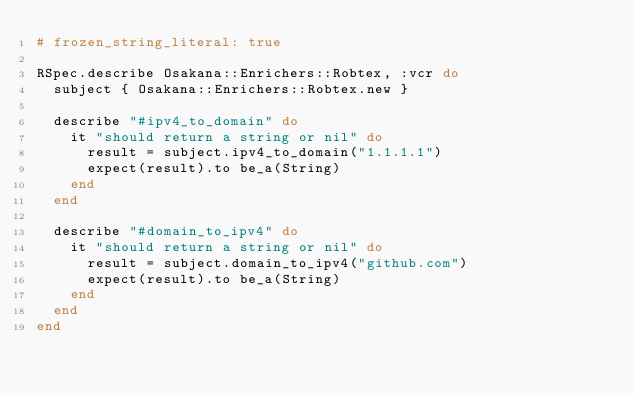<code> <loc_0><loc_0><loc_500><loc_500><_Ruby_># frozen_string_literal: true

RSpec.describe Osakana::Enrichers::Robtex, :vcr do
  subject { Osakana::Enrichers::Robtex.new }

  describe "#ipv4_to_domain" do
    it "should return a string or nil" do
      result = subject.ipv4_to_domain("1.1.1.1")
      expect(result).to be_a(String)
    end
  end

  describe "#domain_to_ipv4" do
    it "should return a string or nil" do
      result = subject.domain_to_ipv4("github.com")
      expect(result).to be_a(String)
    end
  end
end
</code> 